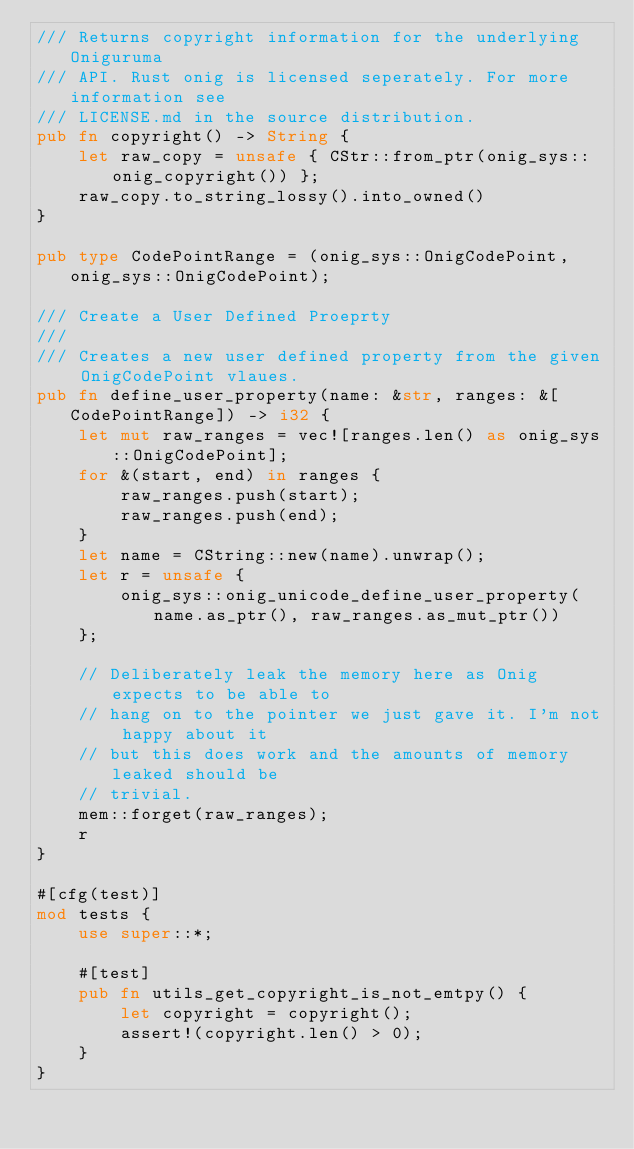Convert code to text. <code><loc_0><loc_0><loc_500><loc_500><_Rust_>/// Returns copyright information for the underlying Oniguruma
/// API. Rust onig is licensed seperately. For more information see
/// LICENSE.md in the source distribution.
pub fn copyright() -> String {
    let raw_copy = unsafe { CStr::from_ptr(onig_sys::onig_copyright()) };
    raw_copy.to_string_lossy().into_owned()
}

pub type CodePointRange = (onig_sys::OnigCodePoint, onig_sys::OnigCodePoint);

/// Create a User Defined Proeprty
///
/// Creates a new user defined property from the given OnigCodePoint vlaues.
pub fn define_user_property(name: &str, ranges: &[CodePointRange]) -> i32 {
    let mut raw_ranges = vec![ranges.len() as onig_sys::OnigCodePoint];
    for &(start, end) in ranges {
        raw_ranges.push(start);
        raw_ranges.push(end);
    }
    let name = CString::new(name).unwrap();
    let r = unsafe {
        onig_sys::onig_unicode_define_user_property(name.as_ptr(), raw_ranges.as_mut_ptr())
    };

    // Deliberately leak the memory here as Onig expects to be able to
    // hang on to the pointer we just gave it. I'm not happy about it
    // but this does work and the amounts of memory leaked should be
    // trivial.
    mem::forget(raw_ranges);
    r
}

#[cfg(test)]
mod tests {
    use super::*;

    #[test]
    pub fn utils_get_copyright_is_not_emtpy() {
        let copyright = copyright();
        assert!(copyright.len() > 0);
    }
}
</code> 